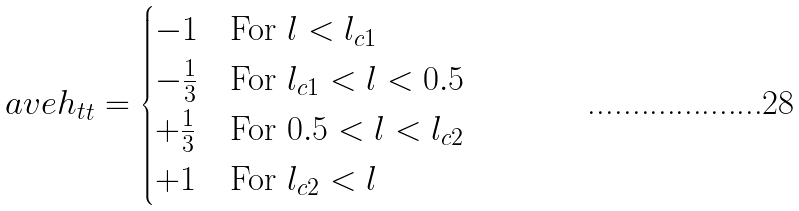<formula> <loc_0><loc_0><loc_500><loc_500>\ a v e { h _ { t } } _ { t } = \begin{cases} - 1 & \text {For } l < l _ { c 1 } \\ - \frac { 1 } { 3 } & \text {For } l _ { c 1 } < l < 0 . 5 \\ + \frac { 1 } { 3 } & \text {For } 0 . 5 < l < l _ { c 2 } \\ + 1 & \text {For } l _ { c 2 } < l \end{cases}</formula> 